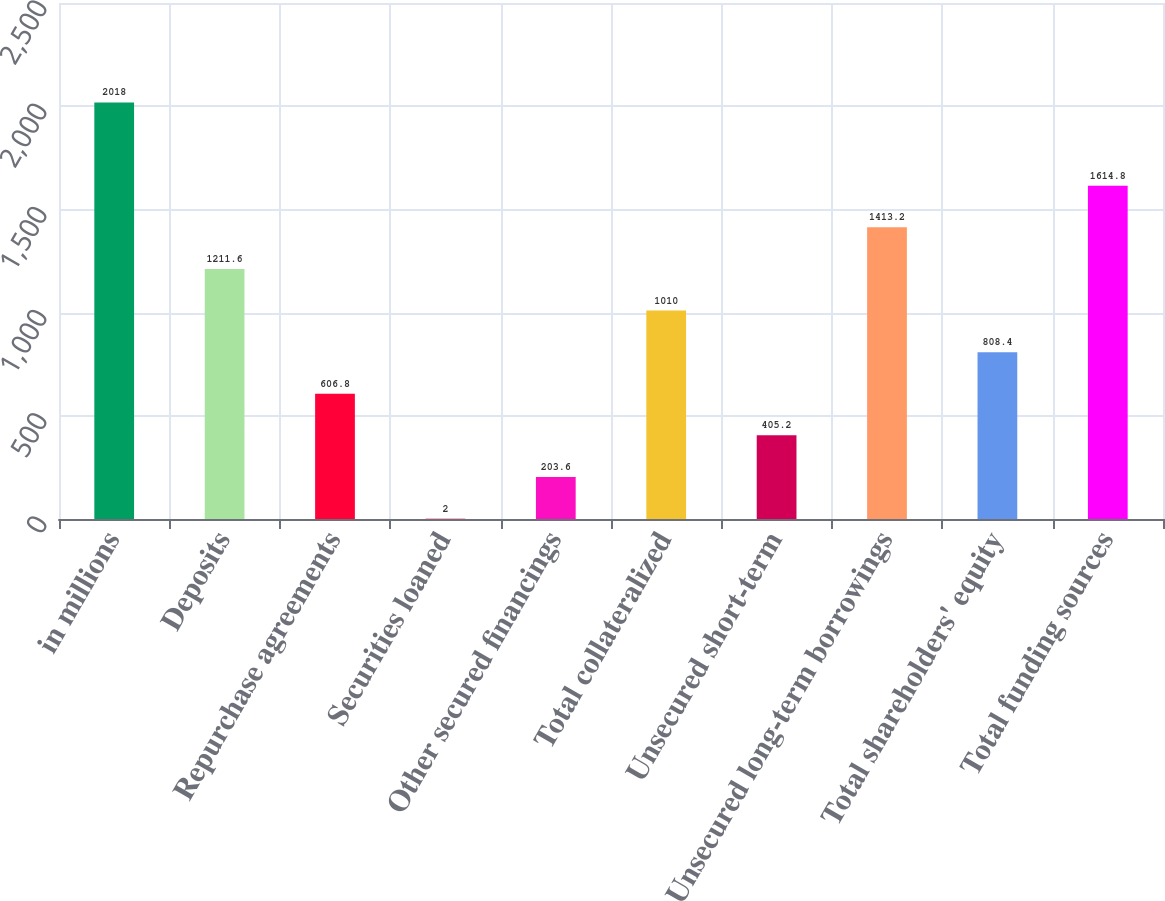Convert chart. <chart><loc_0><loc_0><loc_500><loc_500><bar_chart><fcel>in millions<fcel>Deposits<fcel>Repurchase agreements<fcel>Securities loaned<fcel>Other secured financings<fcel>Total collateralized<fcel>Unsecured short-term<fcel>Unsecured long-term borrowings<fcel>Total shareholders' equity<fcel>Total funding sources<nl><fcel>2018<fcel>1211.6<fcel>606.8<fcel>2<fcel>203.6<fcel>1010<fcel>405.2<fcel>1413.2<fcel>808.4<fcel>1614.8<nl></chart> 